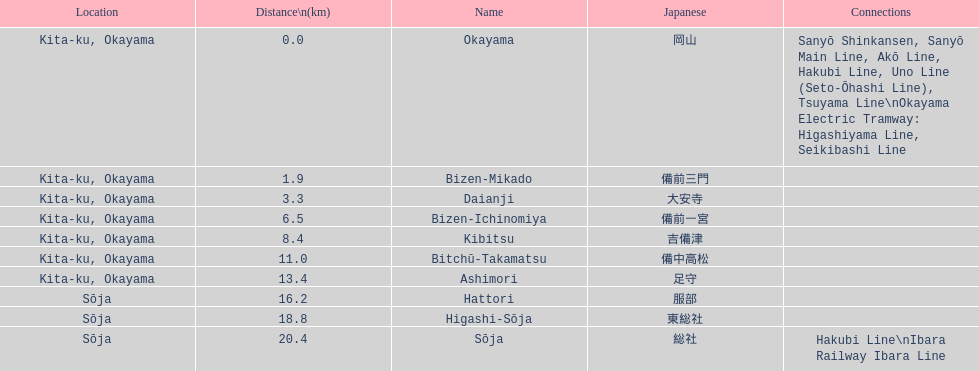Name only the stations that have connections to other lines. Okayama, Sōja. 